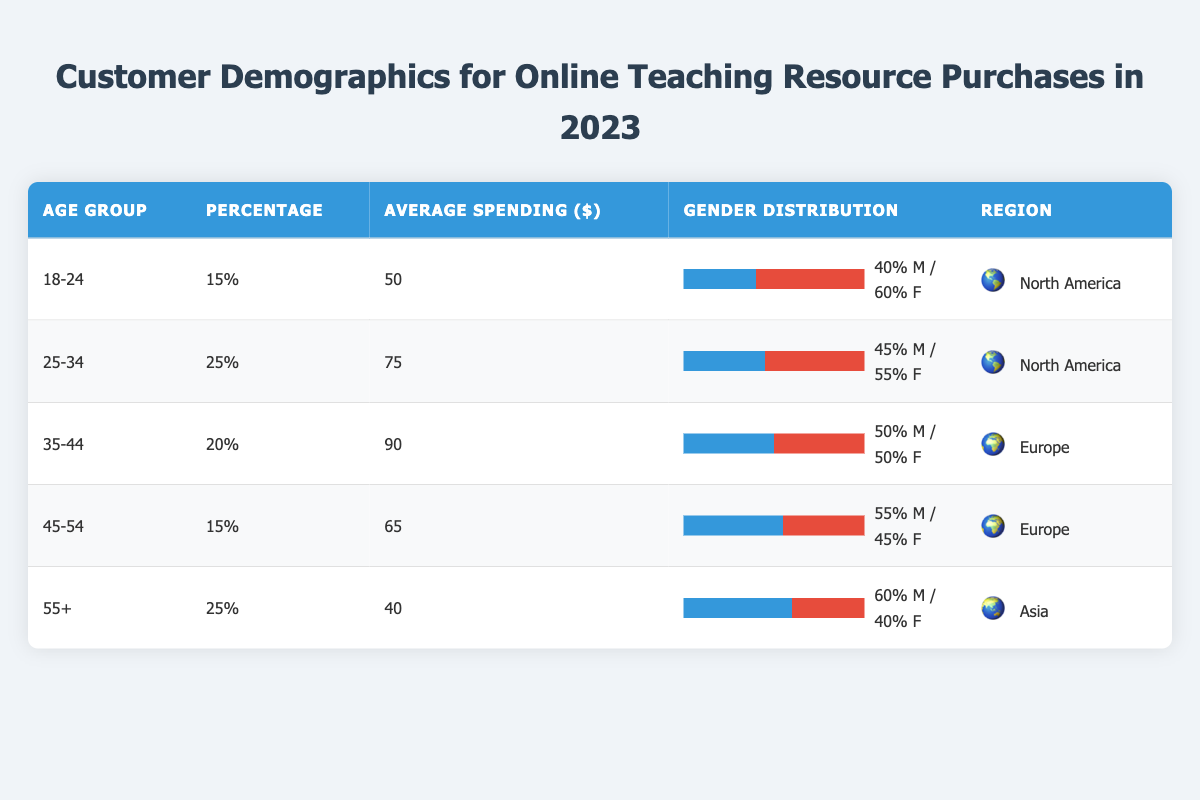What is the average spending for customers aged 25-34? The table shows that the average spending for the age group 25-34 is listed as 75.
Answer: 75 What percentage of customers are aged 55 and older? The table states that 25% of customers fall into the age group of 55 and older.
Answer: 25% Are there more male or female customers in the 18-24 age group? In the 18-24 age group, the gender distribution is 40% male and 60% female, indicating there are more female customers.
Answer: Female What is the average spending across all age groups? The average spending amounts are 50, 75, 90, 65, and 40 for the age groups. The total spending is 50 + 75 + 90 + 65 + 40 = 320, and there are 5 age groups, so the average is 320/5 = 64.
Answer: 64 Do customers aged 45-54 have a higher average spending than those aged 55 and older? The average spending for customers aged 45-54 is 65, while those aged 55 and older average 40. Since 65 is greater than 40, the answer is yes.
Answer: Yes Which region has the highest percentage of customers in the 25-34 age group? The 25-34 age group has a percentage listed in the North America region at 25%. No other region is listed for this age group, indicating that North America is the only region with this percentage.
Answer: North America What is the combined percentage of customers aged 35-44 and 45-54? The percentages for these age groups are 20% for 35-44 and 15% for 45-54. When combined, they total 20 + 15 = 35%.
Answer: 35% Is the male percentage in the 55+ age group higher than that in the 35-44 age group? The male percentage for 55+ is 60%, while for 35-44 it is 50%. Since 60% is greater than 50%, the statement is true.
Answer: Yes What is the gender distribution for customers in the 25-34 age group? The gender distribution for the 25-34 age group shows 45% male and 55% female. This information is directly stated in the table.
Answer: 45% male / 55% female 